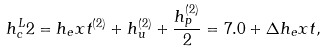<formula> <loc_0><loc_0><loc_500><loc_500>h _ { c } ^ { L } 2 = h _ { e } x t ^ { ( 2 ) } + h _ { u } ^ { ( 2 ) } + \frac { h _ { p } ^ { ( 2 ) } } { 2 } = 7 . 0 + \Delta h _ { e } x t ,</formula> 